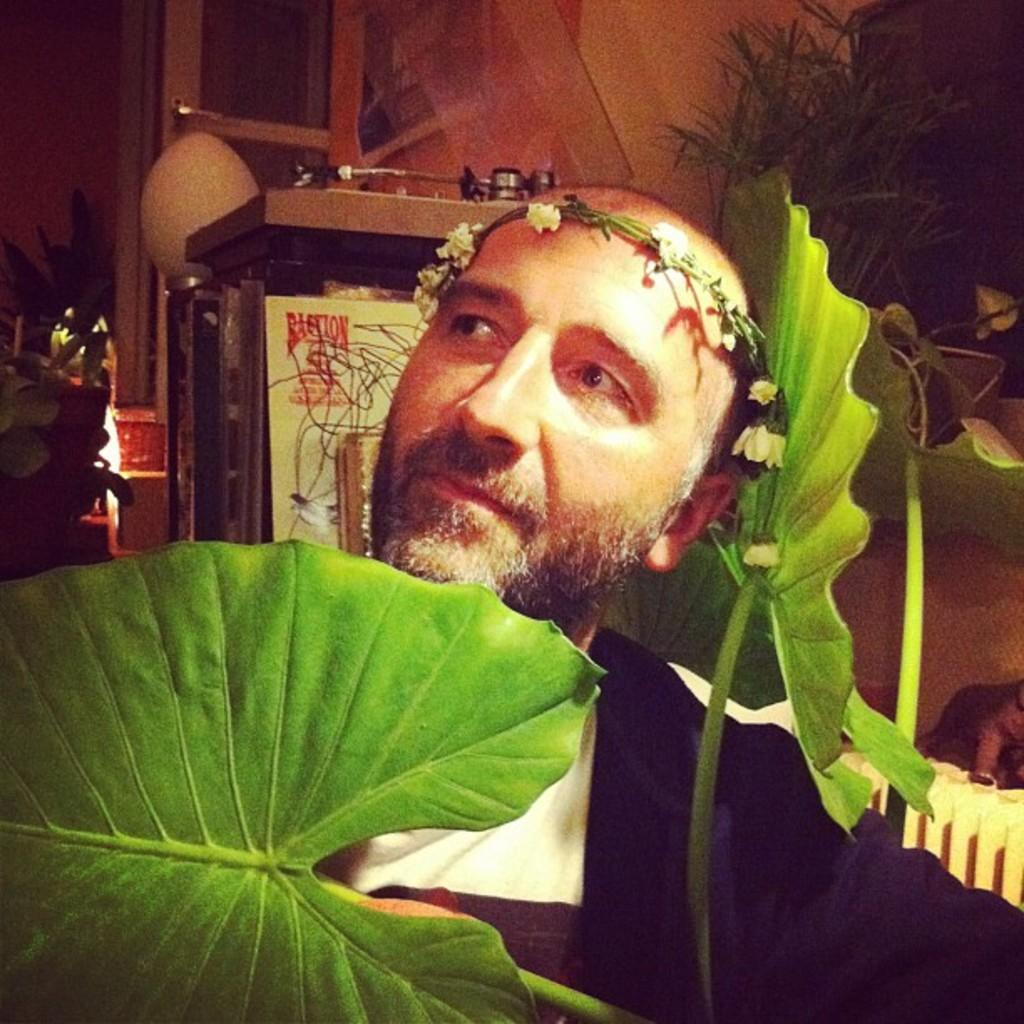Who or what is present in the image? There is a person in the image. What type of natural elements can be seen in the image? Leaves are visible in the image. What object is present in the image? There is a board in the image. What type of pie is being baked in the oven in the image? There is no oven or pie present in the image. 